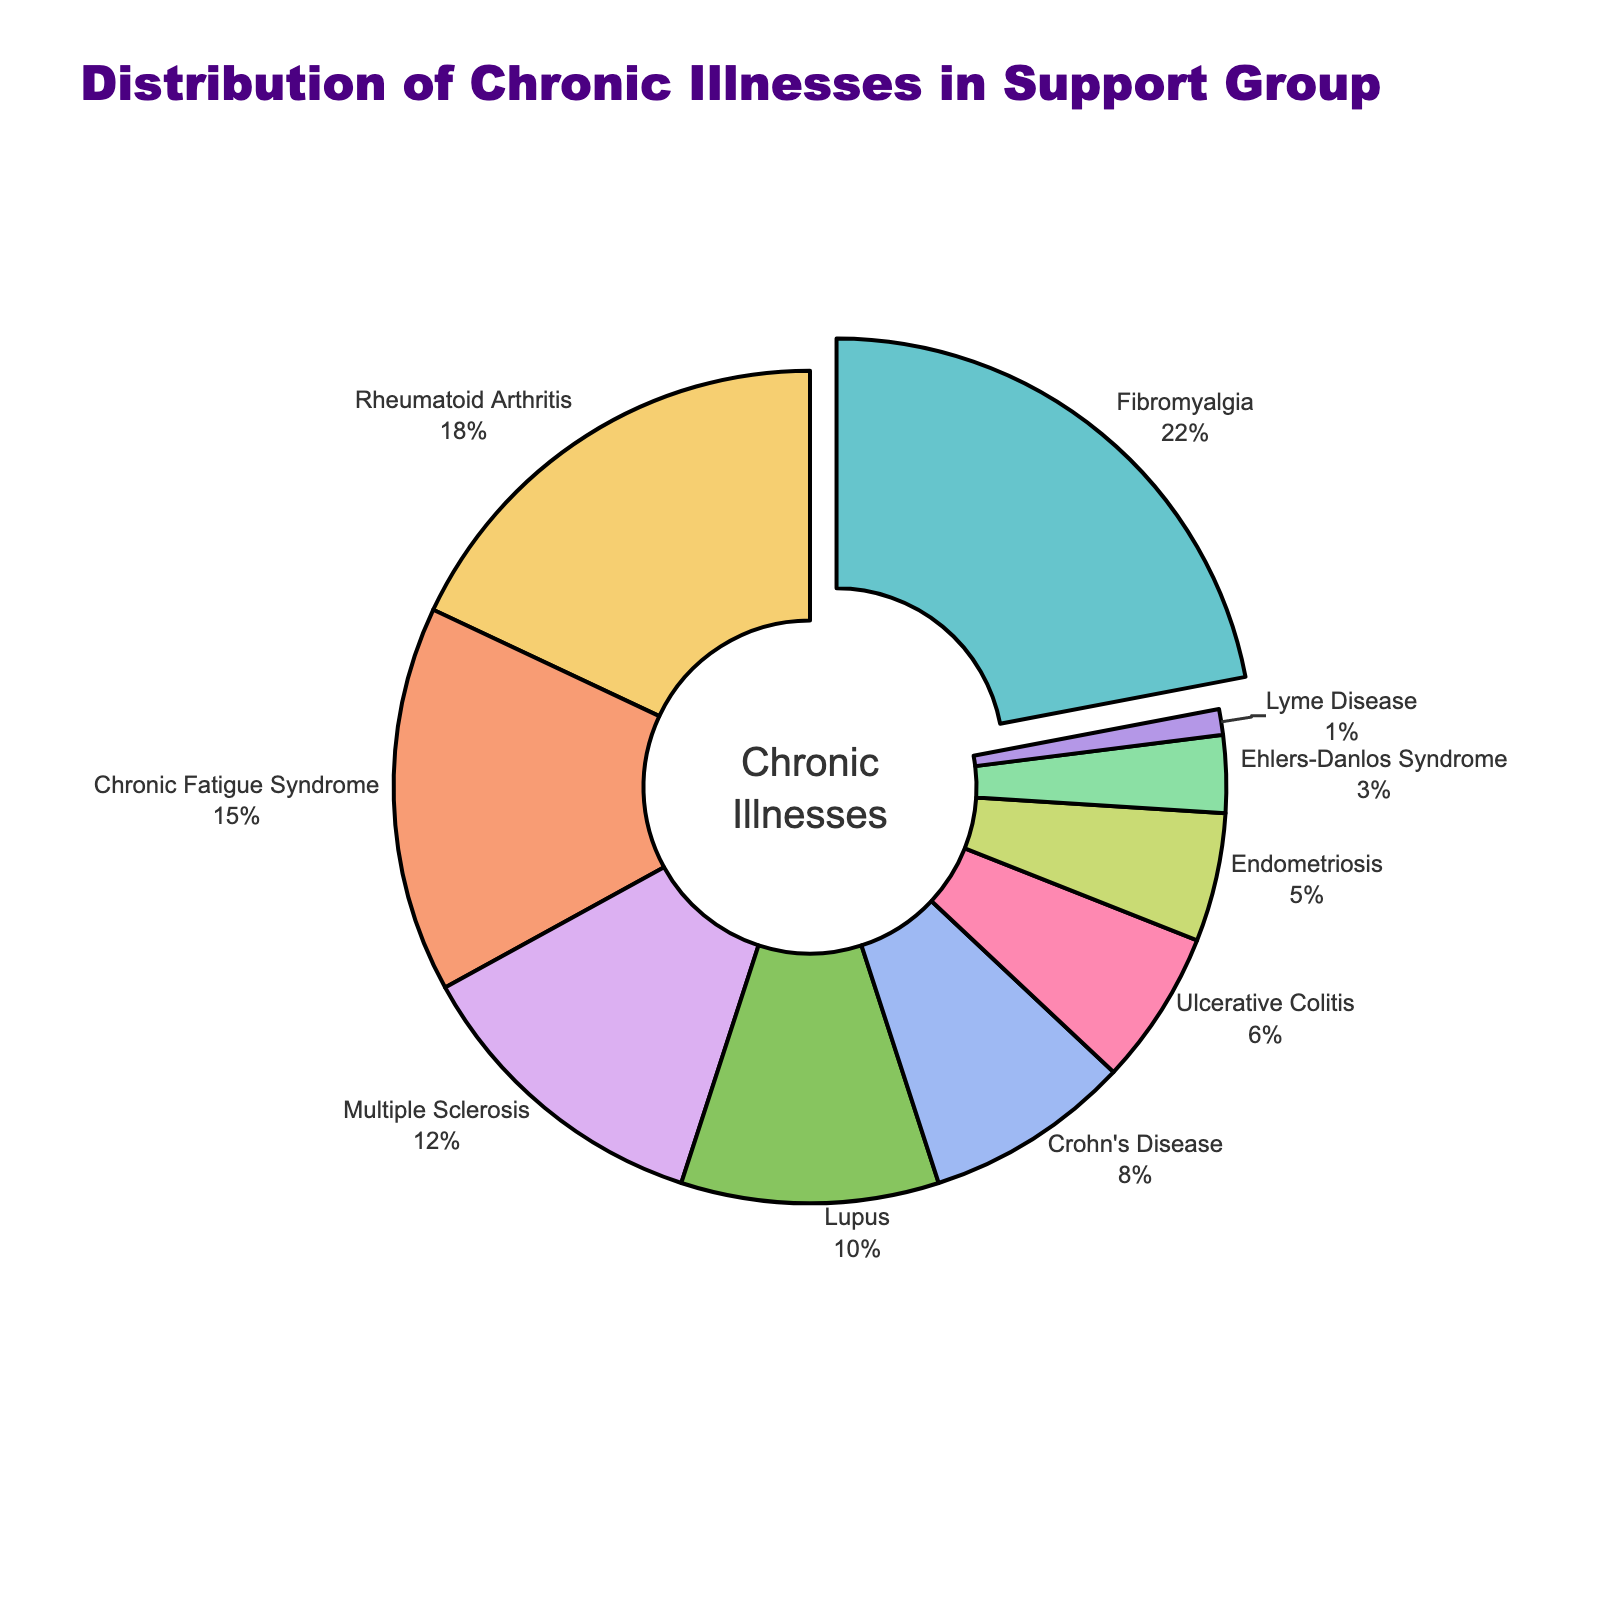What illness has the highest percentage of patients in the support group? The illness with the highest percentage of patients is represented by the largest slice of the pie chart and is also labeled with the highest percentage.
Answer: Fibromyalgia Which two illnesses have a combined percentage closest to 20%? By adding the percentages of different pairs of illnesses, the pair with a total closest to 20% is Rheumatoid Arthritis (18%) and Lyme Disease (1%).
Answer: Rheumatoid Arthritis and Lyme Disease How much larger is the percentage of Fibromyalgia compared to Lupus? The percentage of Fibromyalgia is 22% and the percentage of Lupus is 10%. The difference is 22% - 10% = 12%.
Answer: 12% What percentage of patients in the support group suffer from either Multiple Sclerosis or Endometriosis? The percentage of Multiple Sclerosis is 12% and the percentage of Endometriosis is 5%. Adding these, 12% + 5% = 17%.
Answer: 17% Which illness represents the smallest proportion of patients in the support group? The illness with the smallest proportion is labeled with the smallest percentage and corresponds to the tiniest slice of the pie chart.
Answer: Lyme Disease Arrange the illnesses in order of decreasing percentage of patients. Starting with the largest percentage and moving to the smallest: Fibromyalgia (22%), Rheumatoid Arthritis (18%), Chronic Fatigue Syndrome (15%), Multiple Sclerosis (12%), Lupus (10%), Crohn's Disease (8%), Ulcerative Colitis (6%), Endometriosis (5%), Ehlers-Danlos Syndrome (3%), Lyme Disease (1%).
Answer: Fibromyalgia, Rheumatoid Arthritis, Chronic Fatigue Syndrome, Multiple Sclerosis, Lupus, Crohn's Disease, Ulcerative Colitis, Endometriosis, Ehlers-Danlos Syndrome, Lyme Disease How does the percentage of Chronic Fatigue Syndrome compare to the combined percentage of Ehlers-Danlos Syndrome and Lyme Disease? The percentage of Chronic Fatigue Syndrome is 15%, while the combined percentage of Ehlers-Danlos Syndrome (3%) and Lyme Disease (1%) is 3% + 1% = 4%. Therefore, Chronic Fatigue Syndrome has a higher percentage by 15% - 4% = 11%.
Answer: 11% larger What is the average percentage for all the illnesses represented in the chart? Summing the percentages for each illness: 22 + 18 + 15 + 12 + 10 + 8 + 6 + 5 + 3 + 1 = 100. There are 10 illnesses, so the average is 100 / 10 = 10%.
Answer: 10% Which illness is represented by a slice that is slightly pulled out from the pie chart? The illness with the highest percentage is highlighted by being slightly pulled out from the pie chart to emphasize it.
Answer: Fibromyalgia 